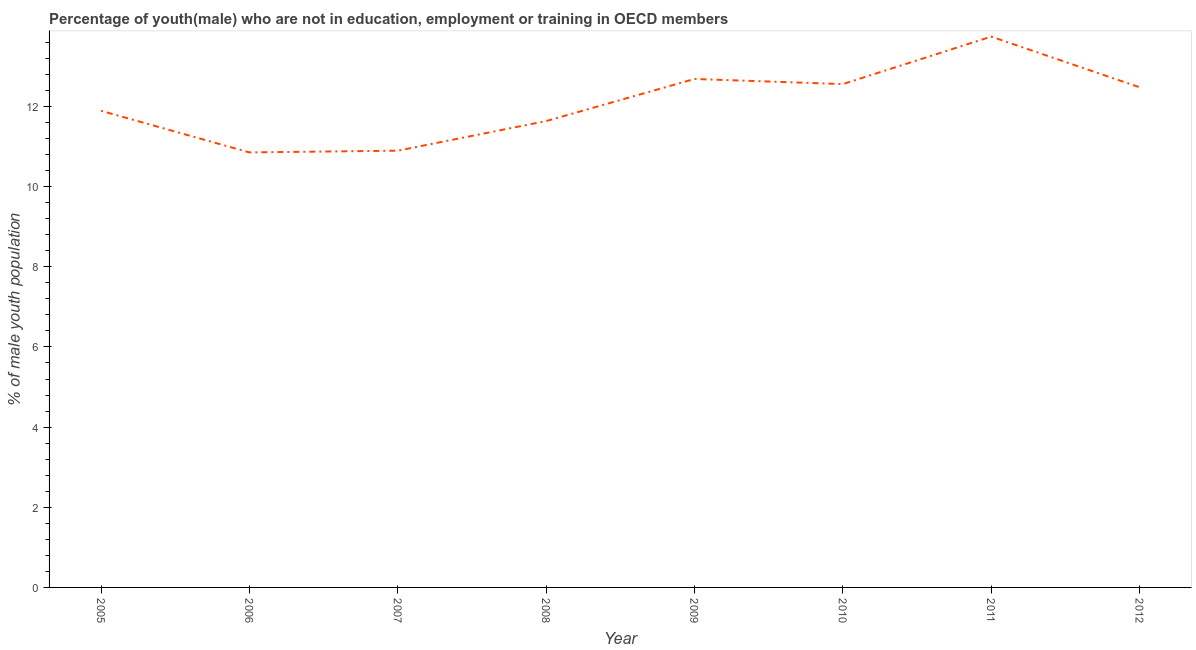What is the unemployed male youth population in 2009?
Provide a succinct answer. 12.69. Across all years, what is the maximum unemployed male youth population?
Keep it short and to the point. 13.74. Across all years, what is the minimum unemployed male youth population?
Your response must be concise. 10.85. In which year was the unemployed male youth population maximum?
Your answer should be compact. 2011. What is the sum of the unemployed male youth population?
Give a very brief answer. 96.75. What is the difference between the unemployed male youth population in 2006 and 2009?
Ensure brevity in your answer.  -1.83. What is the average unemployed male youth population per year?
Offer a very short reply. 12.09. What is the median unemployed male youth population?
Your answer should be compact. 12.19. In how many years, is the unemployed male youth population greater than 4.4 %?
Ensure brevity in your answer.  8. What is the ratio of the unemployed male youth population in 2005 to that in 2010?
Provide a succinct answer. 0.95. What is the difference between the highest and the second highest unemployed male youth population?
Offer a terse response. 1.06. What is the difference between the highest and the lowest unemployed male youth population?
Provide a short and direct response. 2.89. Does the unemployed male youth population monotonically increase over the years?
Ensure brevity in your answer.  No. Are the values on the major ticks of Y-axis written in scientific E-notation?
Your answer should be compact. No. Does the graph contain grids?
Provide a short and direct response. No. What is the title of the graph?
Provide a short and direct response. Percentage of youth(male) who are not in education, employment or training in OECD members. What is the label or title of the X-axis?
Your response must be concise. Year. What is the label or title of the Y-axis?
Your answer should be very brief. % of male youth population. What is the % of male youth population in 2005?
Your answer should be compact. 11.89. What is the % of male youth population in 2006?
Your answer should be very brief. 10.85. What is the % of male youth population in 2007?
Your answer should be compact. 10.9. What is the % of male youth population in 2008?
Offer a very short reply. 11.64. What is the % of male youth population in 2009?
Offer a very short reply. 12.69. What is the % of male youth population in 2010?
Make the answer very short. 12.56. What is the % of male youth population in 2011?
Give a very brief answer. 13.74. What is the % of male youth population in 2012?
Ensure brevity in your answer.  12.48. What is the difference between the % of male youth population in 2005 and 2006?
Provide a short and direct response. 1.04. What is the difference between the % of male youth population in 2005 and 2008?
Give a very brief answer. 0.26. What is the difference between the % of male youth population in 2005 and 2009?
Offer a terse response. -0.79. What is the difference between the % of male youth population in 2005 and 2010?
Provide a succinct answer. -0.67. What is the difference between the % of male youth population in 2005 and 2011?
Your response must be concise. -1.85. What is the difference between the % of male youth population in 2005 and 2012?
Your answer should be very brief. -0.59. What is the difference between the % of male youth population in 2006 and 2007?
Offer a very short reply. -0.04. What is the difference between the % of male youth population in 2006 and 2008?
Keep it short and to the point. -0.78. What is the difference between the % of male youth population in 2006 and 2009?
Provide a short and direct response. -1.83. What is the difference between the % of male youth population in 2006 and 2010?
Give a very brief answer. -1.7. What is the difference between the % of male youth population in 2006 and 2011?
Offer a very short reply. -2.89. What is the difference between the % of male youth population in 2006 and 2012?
Provide a succinct answer. -1.63. What is the difference between the % of male youth population in 2007 and 2008?
Your response must be concise. -0.74. What is the difference between the % of male youth population in 2007 and 2009?
Make the answer very short. -1.79. What is the difference between the % of male youth population in 2007 and 2010?
Keep it short and to the point. -1.66. What is the difference between the % of male youth population in 2007 and 2011?
Your response must be concise. -2.85. What is the difference between the % of male youth population in 2007 and 2012?
Provide a succinct answer. -1.58. What is the difference between the % of male youth population in 2008 and 2009?
Your response must be concise. -1.05. What is the difference between the % of male youth population in 2008 and 2010?
Offer a terse response. -0.92. What is the difference between the % of male youth population in 2008 and 2011?
Provide a short and direct response. -2.11. What is the difference between the % of male youth population in 2008 and 2012?
Your response must be concise. -0.84. What is the difference between the % of male youth population in 2009 and 2010?
Your response must be concise. 0.13. What is the difference between the % of male youth population in 2009 and 2011?
Your answer should be very brief. -1.06. What is the difference between the % of male youth population in 2009 and 2012?
Keep it short and to the point. 0.21. What is the difference between the % of male youth population in 2010 and 2011?
Keep it short and to the point. -1.18. What is the difference between the % of male youth population in 2010 and 2012?
Ensure brevity in your answer.  0.08. What is the difference between the % of male youth population in 2011 and 2012?
Ensure brevity in your answer.  1.26. What is the ratio of the % of male youth population in 2005 to that in 2006?
Make the answer very short. 1.1. What is the ratio of the % of male youth population in 2005 to that in 2007?
Offer a very short reply. 1.09. What is the ratio of the % of male youth population in 2005 to that in 2009?
Offer a very short reply. 0.94. What is the ratio of the % of male youth population in 2005 to that in 2010?
Offer a very short reply. 0.95. What is the ratio of the % of male youth population in 2005 to that in 2011?
Your answer should be compact. 0.86. What is the ratio of the % of male youth population in 2005 to that in 2012?
Offer a very short reply. 0.95. What is the ratio of the % of male youth population in 2006 to that in 2007?
Give a very brief answer. 1. What is the ratio of the % of male youth population in 2006 to that in 2008?
Make the answer very short. 0.93. What is the ratio of the % of male youth population in 2006 to that in 2009?
Offer a very short reply. 0.86. What is the ratio of the % of male youth population in 2006 to that in 2010?
Your answer should be compact. 0.86. What is the ratio of the % of male youth population in 2006 to that in 2011?
Your answer should be very brief. 0.79. What is the ratio of the % of male youth population in 2006 to that in 2012?
Keep it short and to the point. 0.87. What is the ratio of the % of male youth population in 2007 to that in 2008?
Your response must be concise. 0.94. What is the ratio of the % of male youth population in 2007 to that in 2009?
Provide a short and direct response. 0.86. What is the ratio of the % of male youth population in 2007 to that in 2010?
Your answer should be compact. 0.87. What is the ratio of the % of male youth population in 2007 to that in 2011?
Ensure brevity in your answer.  0.79. What is the ratio of the % of male youth population in 2007 to that in 2012?
Make the answer very short. 0.87. What is the ratio of the % of male youth population in 2008 to that in 2009?
Your response must be concise. 0.92. What is the ratio of the % of male youth population in 2008 to that in 2010?
Provide a short and direct response. 0.93. What is the ratio of the % of male youth population in 2008 to that in 2011?
Your answer should be very brief. 0.85. What is the ratio of the % of male youth population in 2008 to that in 2012?
Give a very brief answer. 0.93. What is the ratio of the % of male youth population in 2009 to that in 2010?
Offer a very short reply. 1.01. What is the ratio of the % of male youth population in 2009 to that in 2011?
Give a very brief answer. 0.92. What is the ratio of the % of male youth population in 2009 to that in 2012?
Your answer should be compact. 1.02. What is the ratio of the % of male youth population in 2010 to that in 2011?
Offer a terse response. 0.91. What is the ratio of the % of male youth population in 2011 to that in 2012?
Offer a very short reply. 1.1. 